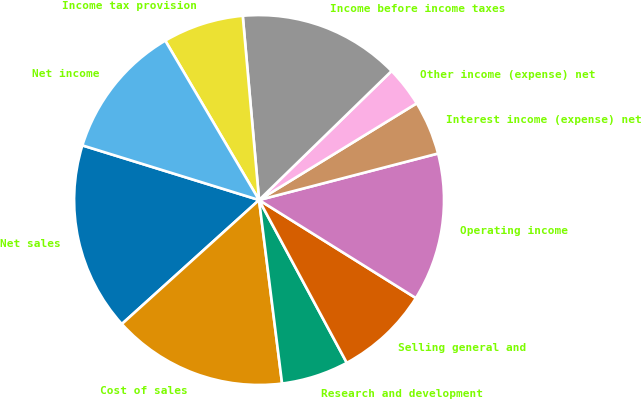Convert chart. <chart><loc_0><loc_0><loc_500><loc_500><pie_chart><fcel>Net sales<fcel>Cost of sales<fcel>Research and development<fcel>Selling general and<fcel>Operating income<fcel>Interest income (expense) net<fcel>Other income (expense) net<fcel>Income before income taxes<fcel>Income tax provision<fcel>Net income<nl><fcel>16.47%<fcel>15.29%<fcel>5.88%<fcel>8.24%<fcel>12.94%<fcel>4.71%<fcel>3.53%<fcel>14.12%<fcel>7.06%<fcel>11.76%<nl></chart> 